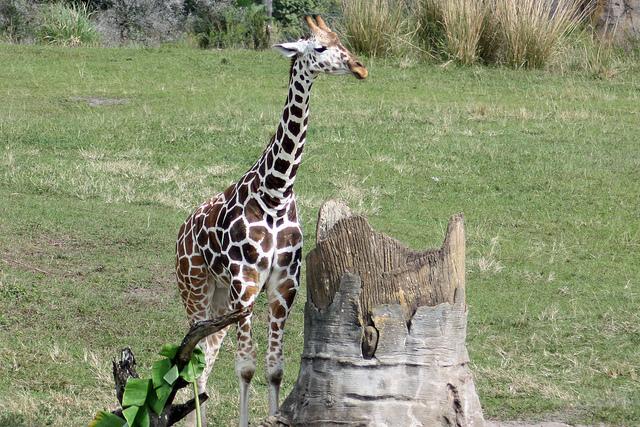What is in the top left corner?
Quick response, please. Grass. Why are there tree trunks at the edge of the field?
Give a very brief answer. Where lightning struck. What is on the ground near the standing giraffe?
Short answer required. Tree stump. What species of giraffe is this?
Write a very short answer. African. Is this giraffe very tall?
Give a very brief answer. No. How many giraffes are in the scene?
Be succinct. 1. 